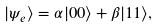<formula> <loc_0><loc_0><loc_500><loc_500>| \psi _ { e } \rangle = \alpha | 0 0 \rangle + \beta | 1 1 \rangle ,</formula> 